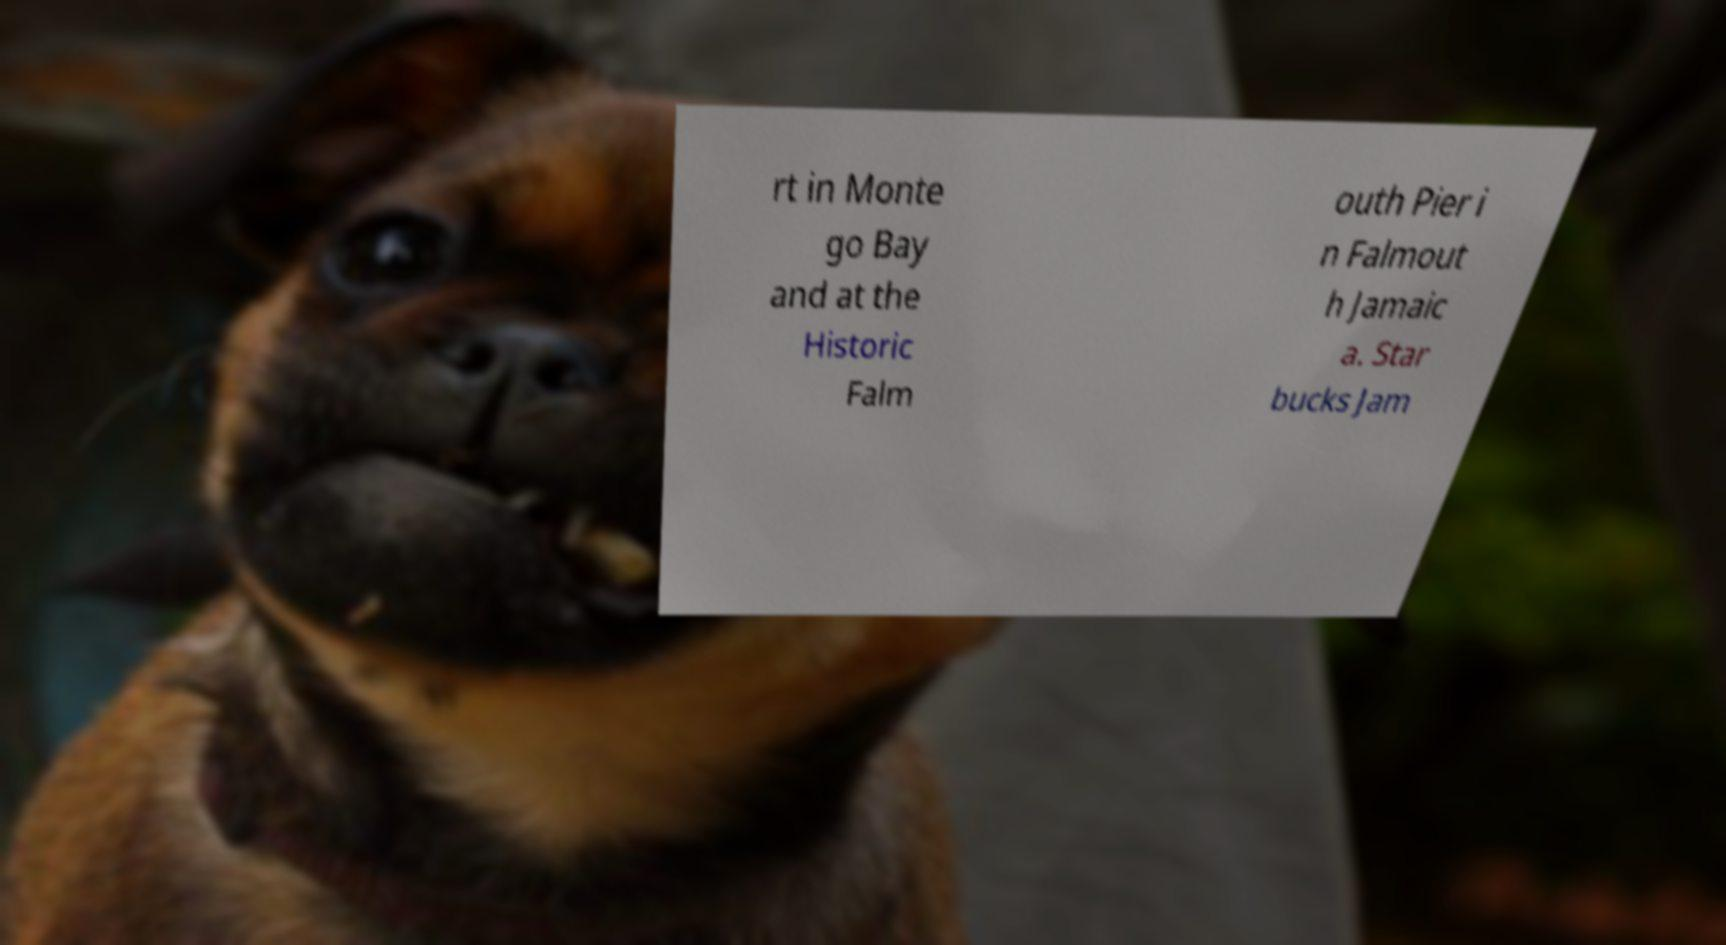Could you assist in decoding the text presented in this image and type it out clearly? rt in Monte go Bay and at the Historic Falm outh Pier i n Falmout h Jamaic a. Star bucks Jam 